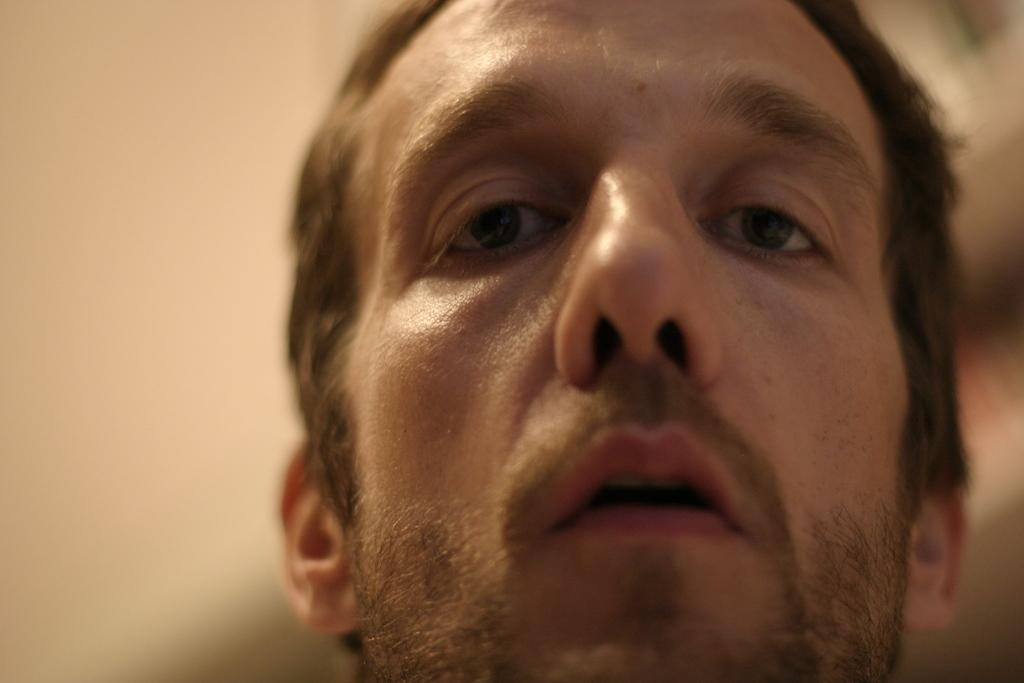What is the main subject of the image? There is a person's face in the image. Can you describe the background of the image? The background of the image is blurred. What type of key is being used to unlock the zephyr in the image? There is no key or zephyr present in the image; it only features a person's face with a blurred background. 